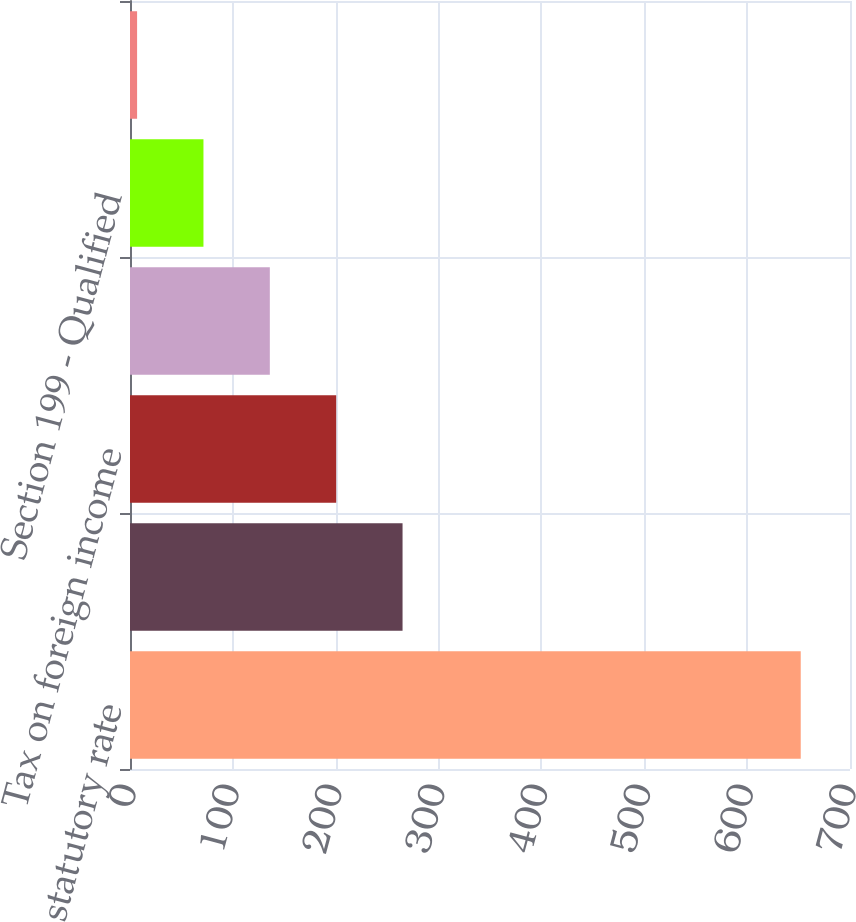Convert chart. <chart><loc_0><loc_0><loc_500><loc_500><bar_chart><fcel>statutory rate<fcel>State taxes net of federal tax<fcel>Tax on foreign income<fcel>Utilization of foreign tax<fcel>Section 199 - Qualified<fcel>Other<nl><fcel>652.1<fcel>264.98<fcel>200.46<fcel>135.94<fcel>71.42<fcel>6.9<nl></chart> 